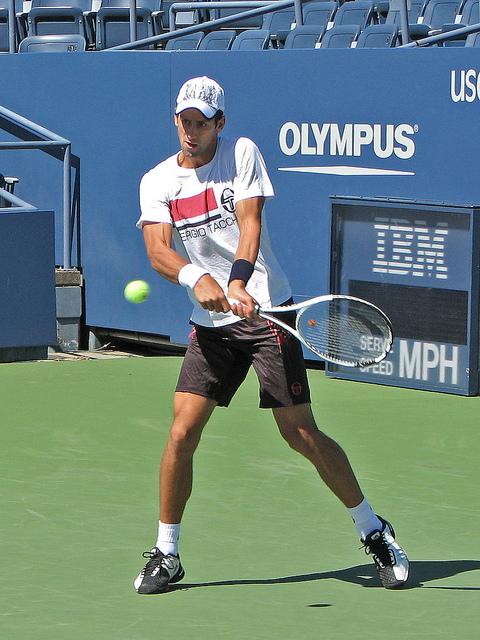What color is the ball in mid air?
Quick response, please. Yellow. What is the man holding?
Concise answer only. Tennis racket. What color is the wall behind the man?
Quick response, please. Blue. 